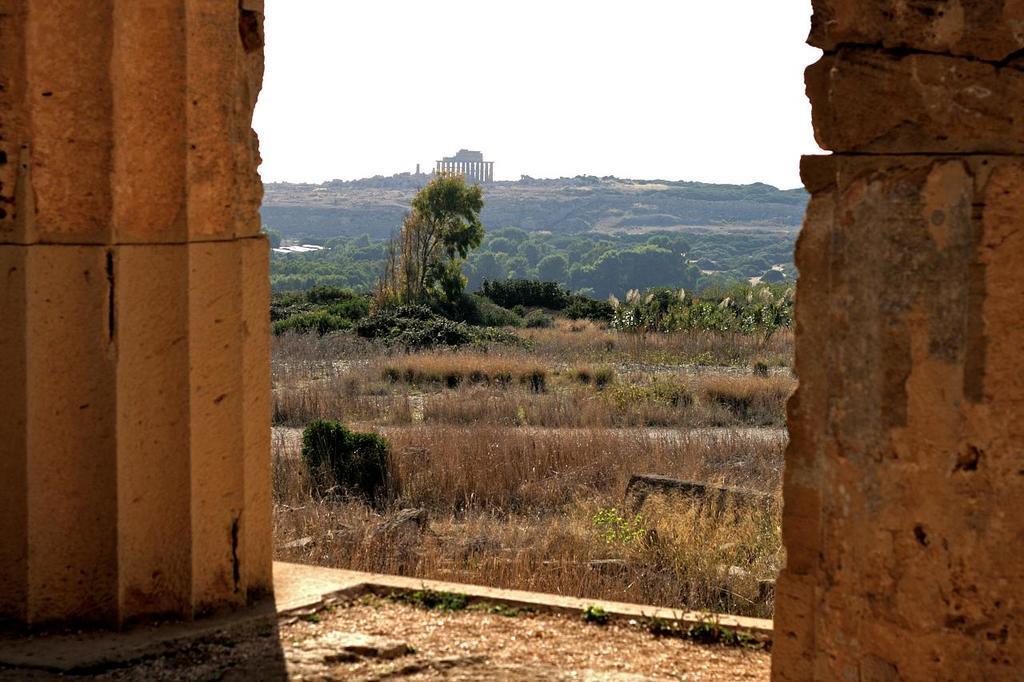How would you summarize this image in a sentence or two? This image is clicked outside. In the front, we can see many trees and plants along with mountains. On the left and right, there are walls. At the top, there is sky. 